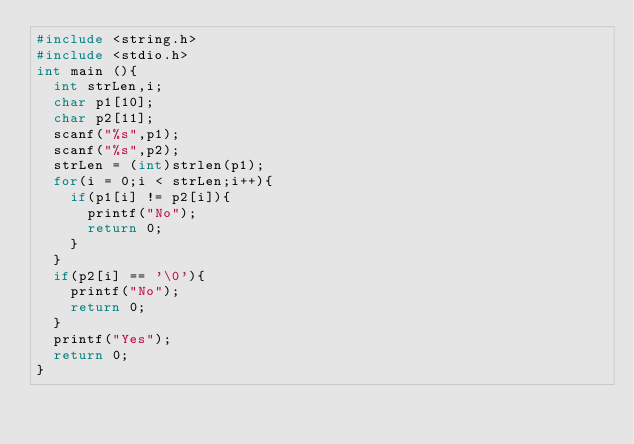<code> <loc_0><loc_0><loc_500><loc_500><_C_>#include <string.h>
#include <stdio.h>
int main (){
  int strLen,i;
  char p1[10];
  char p2[11];
  scanf("%s",p1);
  scanf("%s",p2);
  strLen = (int)strlen(p1);
  for(i = 0;i < strLen;i++){
	if(p1[i] != p2[i]){
      printf("No");
      return 0;
    }
  }
  if(p2[i] == '\0'){
    printf("No");
    return 0;  
  }
  printf("Yes");
  return 0;
}
</code> 